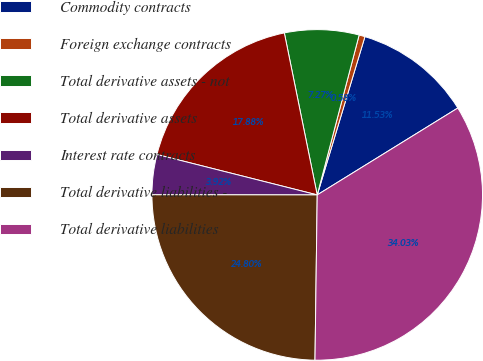Convert chart to OTSL. <chart><loc_0><loc_0><loc_500><loc_500><pie_chart><fcel>Commodity contracts<fcel>Foreign exchange contracts<fcel>Total derivative assets - not<fcel>Total derivative assets<fcel>Interest rate contracts<fcel>Total derivative liabilities -<fcel>Total derivative liabilities<nl><fcel>11.53%<fcel>0.58%<fcel>7.27%<fcel>17.88%<fcel>3.92%<fcel>24.8%<fcel>34.03%<nl></chart> 